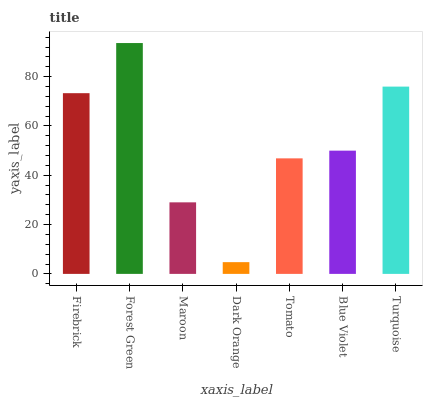Is Dark Orange the minimum?
Answer yes or no. Yes. Is Forest Green the maximum?
Answer yes or no. Yes. Is Maroon the minimum?
Answer yes or no. No. Is Maroon the maximum?
Answer yes or no. No. Is Forest Green greater than Maroon?
Answer yes or no. Yes. Is Maroon less than Forest Green?
Answer yes or no. Yes. Is Maroon greater than Forest Green?
Answer yes or no. No. Is Forest Green less than Maroon?
Answer yes or no. No. Is Blue Violet the high median?
Answer yes or no. Yes. Is Blue Violet the low median?
Answer yes or no. Yes. Is Firebrick the high median?
Answer yes or no. No. Is Firebrick the low median?
Answer yes or no. No. 